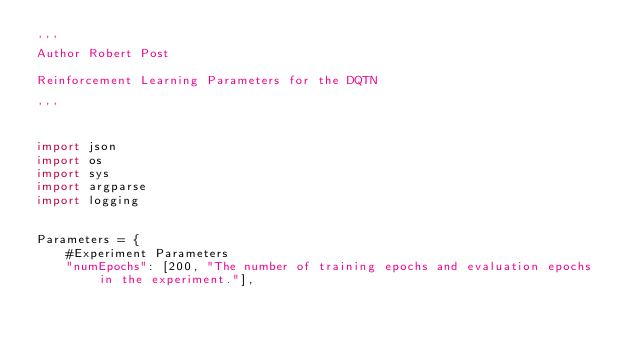<code> <loc_0><loc_0><loc_500><loc_500><_Python_>'''
Author Robert Post

Reinforcement Learning Parameters for the DQTN

'''


import json
import os
import sys
import argparse
import logging


Parameters = {
    #Experiment Parameters
    "numEpochs": [200, "The number of training epochs and evaluation epochs in the experiment."],</code> 